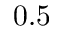<formula> <loc_0><loc_0><loc_500><loc_500>0 . 5</formula> 